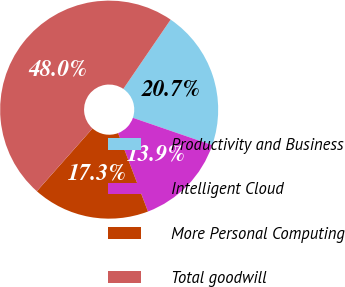Convert chart to OTSL. <chart><loc_0><loc_0><loc_500><loc_500><pie_chart><fcel>Productivity and Business<fcel>Intelligent Cloud<fcel>More Personal Computing<fcel>Total goodwill<nl><fcel>20.74%<fcel>13.93%<fcel>17.34%<fcel>47.99%<nl></chart> 